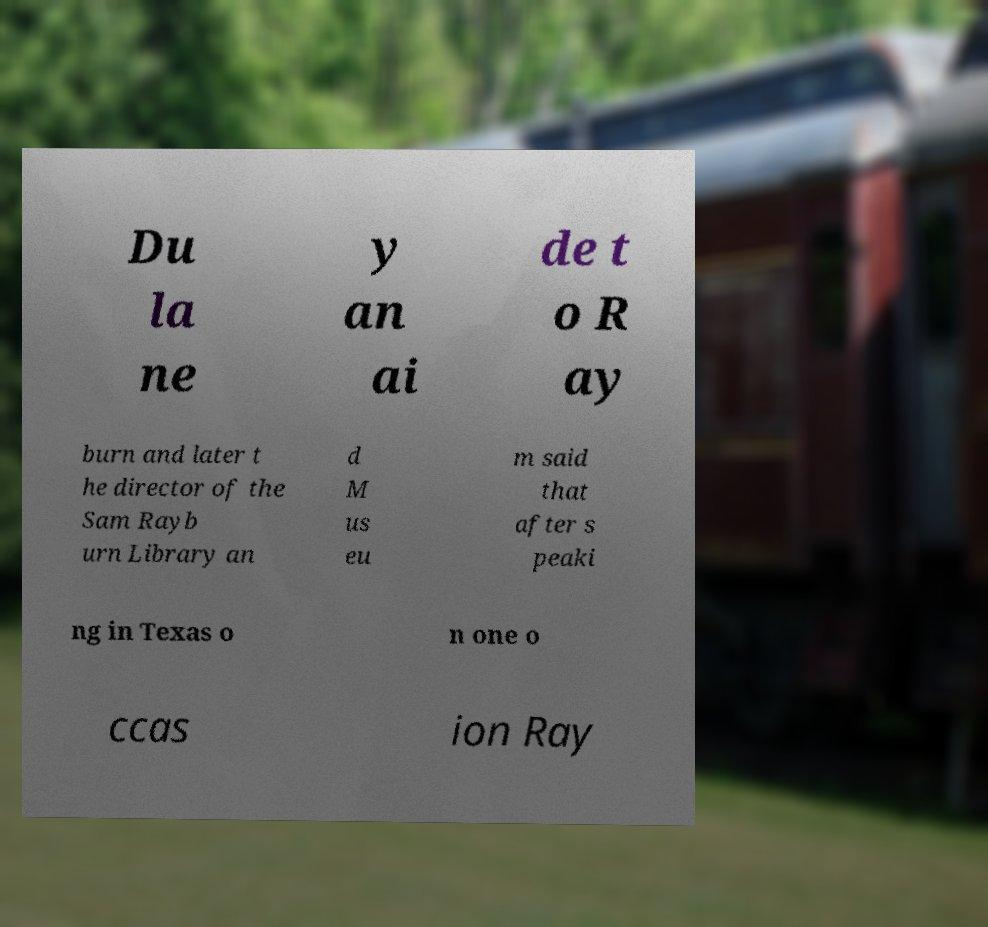Can you accurately transcribe the text from the provided image for me? Du la ne y an ai de t o R ay burn and later t he director of the Sam Rayb urn Library an d M us eu m said that after s peaki ng in Texas o n one o ccas ion Ray 